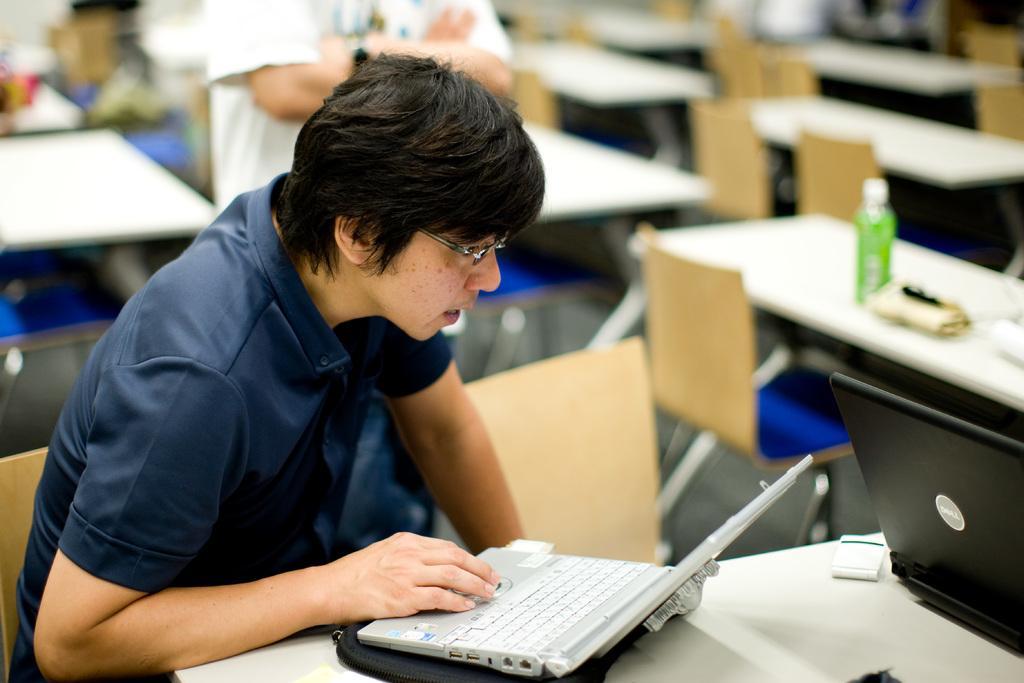Could you give a brief overview of what you see in this image? In this picture there is a person wearing blue dress is operating a laptop which is placed on a table in front of him and there is another laptop in the right corner and there are few chairs and tables in the background. 